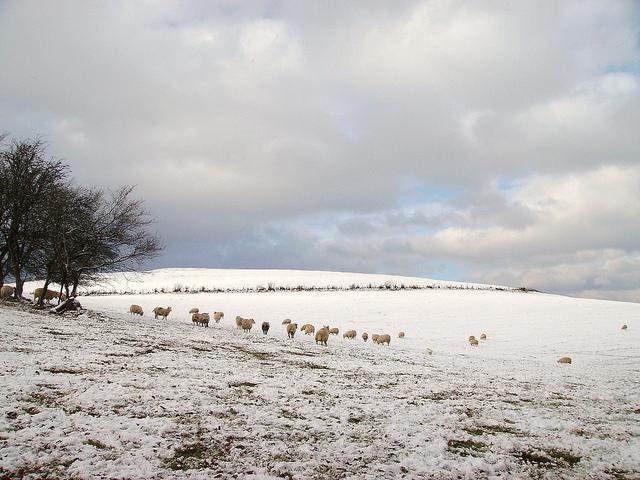Is the snow deep?
Be succinct. No. Would people vacation here?
Give a very brief answer. No. What kind of animal are these?
Concise answer only. Sheep. What is this place called?
Quick response, please. Field. What animal is in the picture?
Give a very brief answer. Sheep. Is this on the beach?
Be succinct. No. Does this place seem to be fenced in?
Write a very short answer. No. What shape are they standing in?
Quick response, please. Square. 